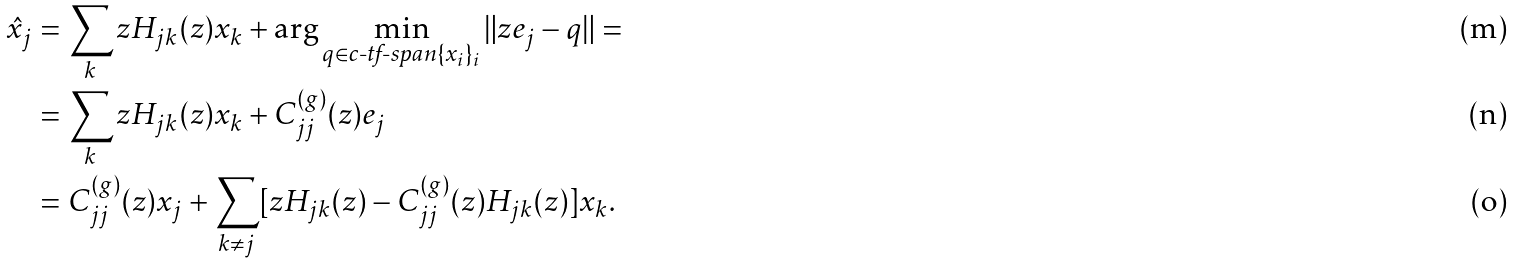<formula> <loc_0><loc_0><loc_500><loc_500>\hat { x } _ { j } & = \sum _ { k } z H _ { j k } ( z ) x _ { k } + \arg \min _ { q \in \text {c-tf-span} \{ x _ { i } \} _ { i } } \| z e _ { j } - q \| = \\ & = \sum _ { k } z H _ { j k } ( z ) x _ { k } + C ^ { ( g ) } _ { j j } ( z ) e _ { j } \\ & = C ^ { ( g ) } _ { j j } ( z ) x _ { j } + \sum _ { k \neq j } [ z H _ { j k } ( z ) - C ^ { ( g ) } _ { j j } ( z ) H _ { j k } ( z ) ] x _ { k } .</formula> 